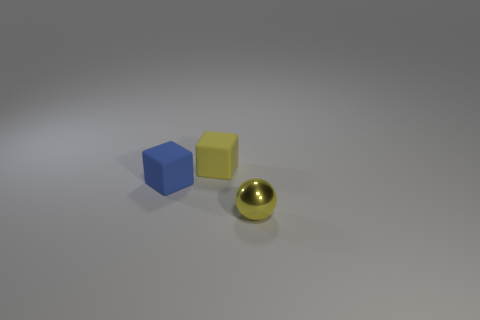There is a thing that is in front of the yellow rubber cube and behind the small yellow shiny ball; what shape is it?
Provide a succinct answer. Cube. What color is the metallic ball that is the same size as the yellow matte thing?
Offer a terse response. Yellow. Is there a matte cube of the same color as the tiny sphere?
Provide a short and direct response. Yes. Do the yellow thing that is left of the small yellow metallic object and the yellow thing in front of the tiny blue rubber thing have the same size?
Provide a short and direct response. Yes. There is a thing that is in front of the yellow rubber cube and to the left of the shiny object; what is it made of?
Offer a very short reply. Rubber. What is the size of the object that is the same color as the ball?
Provide a short and direct response. Small. What number of other objects are there of the same size as the blue cube?
Ensure brevity in your answer.  2. There is a object in front of the small blue matte object; what is it made of?
Ensure brevity in your answer.  Metal. Does the small blue object have the same shape as the yellow rubber thing?
Your response must be concise. Yes. What number of other things are there of the same shape as the yellow matte thing?
Provide a short and direct response. 1. 